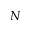<formula> <loc_0><loc_0><loc_500><loc_500>N</formula> 